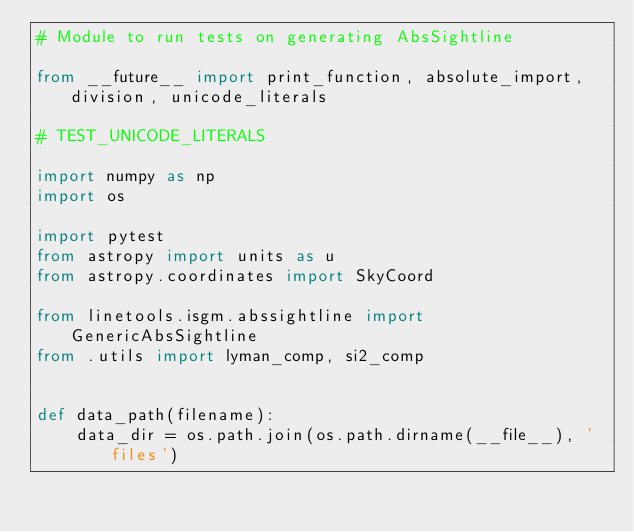Convert code to text. <code><loc_0><loc_0><loc_500><loc_500><_Python_># Module to run tests on generating AbsSightline

from __future__ import print_function, absolute_import, division, unicode_literals

# TEST_UNICODE_LITERALS

import numpy as np
import os

import pytest
from astropy import units as u
from astropy.coordinates import SkyCoord

from linetools.isgm.abssightline import GenericAbsSightline
from .utils import lyman_comp, si2_comp


def data_path(filename):
    data_dir = os.path.join(os.path.dirname(__file__), 'files')</code> 